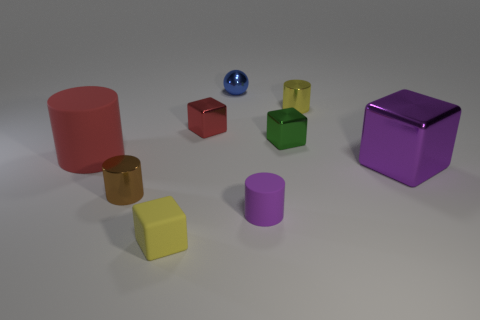Subtract 1 blocks. How many blocks are left? 3 Add 1 cyan matte things. How many objects exist? 10 Subtract all spheres. How many objects are left? 8 Subtract 0 red spheres. How many objects are left? 9 Subtract all small yellow things. Subtract all small cylinders. How many objects are left? 4 Add 1 red metal objects. How many red metal objects are left? 2 Add 3 brown metallic things. How many brown metallic things exist? 4 